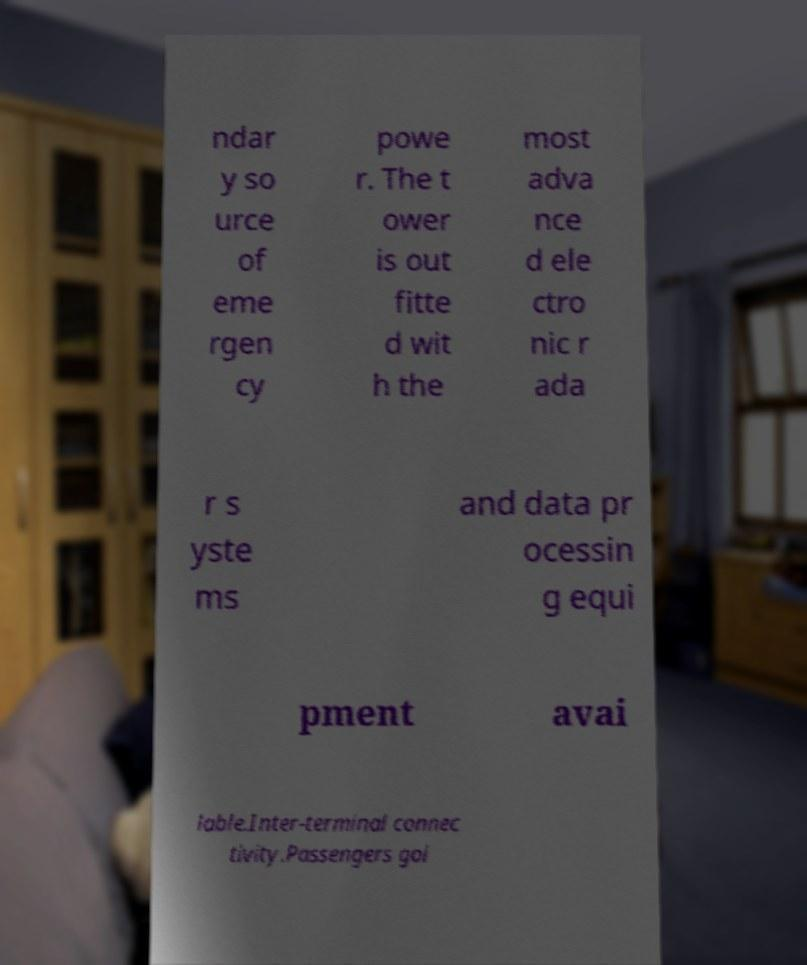Please read and relay the text visible in this image. What does it say? ndar y so urce of eme rgen cy powe r. The t ower is out fitte d wit h the most adva nce d ele ctro nic r ada r s yste ms and data pr ocessin g equi pment avai lable.Inter-terminal connec tivity.Passengers goi 